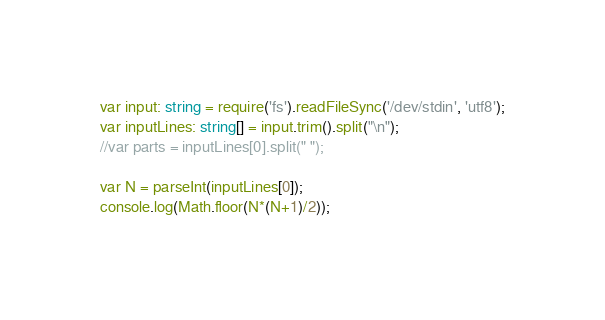<code> <loc_0><loc_0><loc_500><loc_500><_TypeScript_>var input: string = require('fs').readFileSync('/dev/stdin', 'utf8');
var inputLines: string[] = input.trim().split("\n");
//var parts = inputLines[0].split(" ");

var N = parseInt(inputLines[0]);
console.log(Math.floor(N*(N+1)/2));</code> 